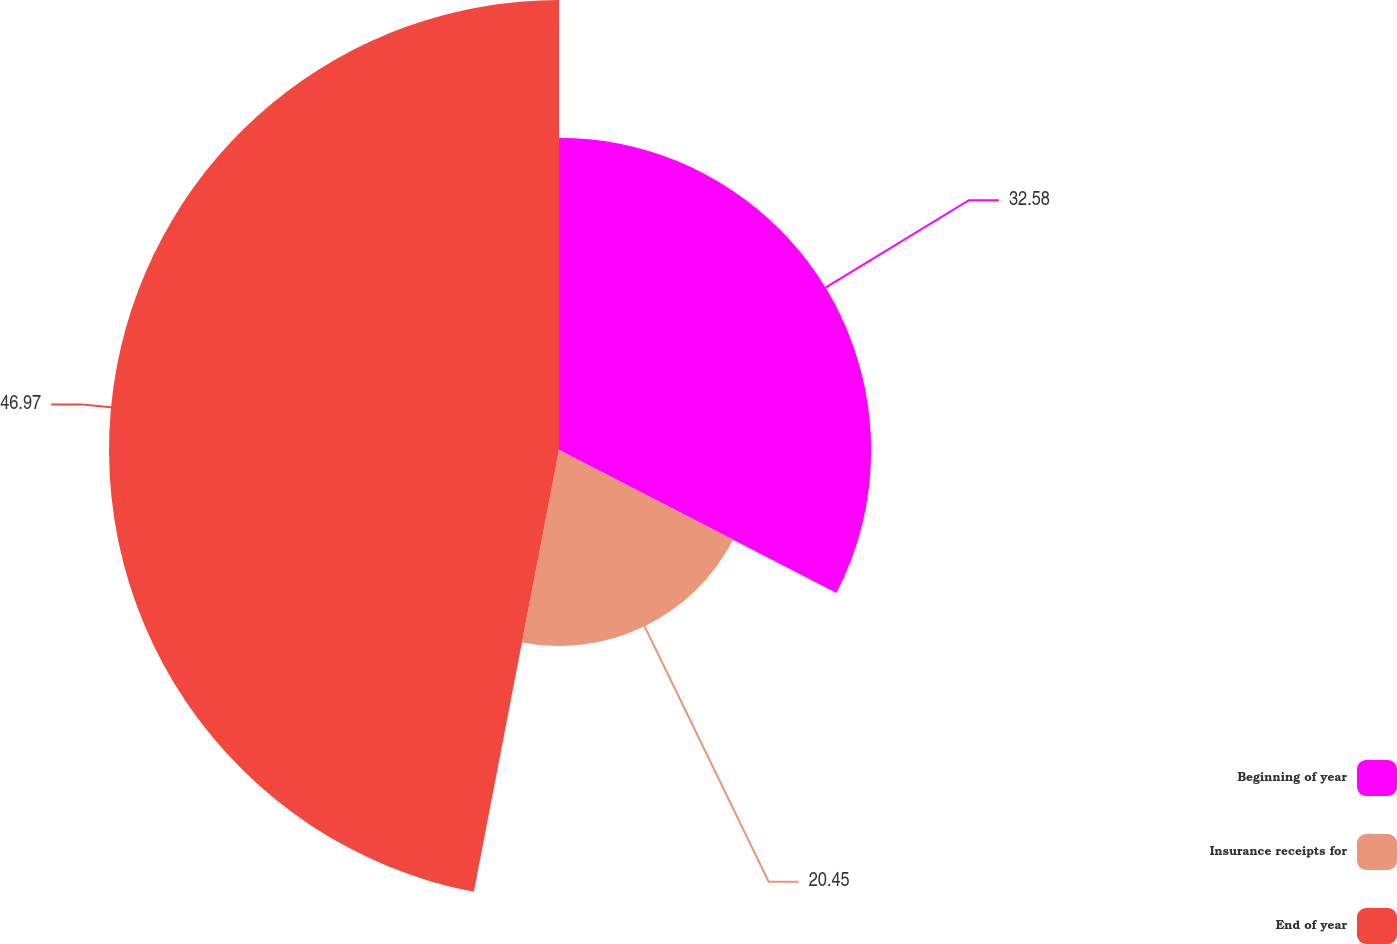Convert chart. <chart><loc_0><loc_0><loc_500><loc_500><pie_chart><fcel>Beginning of year<fcel>Insurance receipts for<fcel>End of year<nl><fcel>32.58%<fcel>20.45%<fcel>46.97%<nl></chart> 